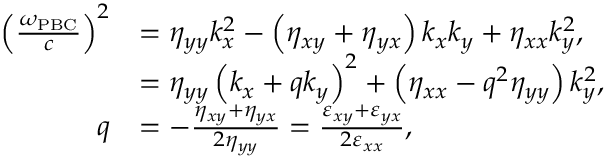Convert formula to latex. <formula><loc_0><loc_0><loc_500><loc_500>\begin{array} { r l } { \left ( \frac { \omega _ { P B C } } { c } \right ) ^ { 2 } } & { = \eta _ { y y } k _ { x } ^ { 2 } - \left ( \eta _ { x y } + \eta _ { y x } \right ) k _ { x } k _ { y } + \eta _ { x x } k _ { y } ^ { 2 } , } \\ & { = \eta _ { y y } \left ( k _ { x } + q k _ { y } \right ) ^ { 2 } + \left ( \eta _ { x x } - q ^ { 2 } \eta _ { y y } \right ) k _ { y } ^ { 2 } , } \\ { q } & { = - \frac { \eta _ { x y } + \eta _ { y x } } { 2 \eta _ { y y } } = \frac { \varepsilon _ { x y } + \varepsilon _ { y x } } { 2 \varepsilon _ { x x } } , } \end{array}</formula> 